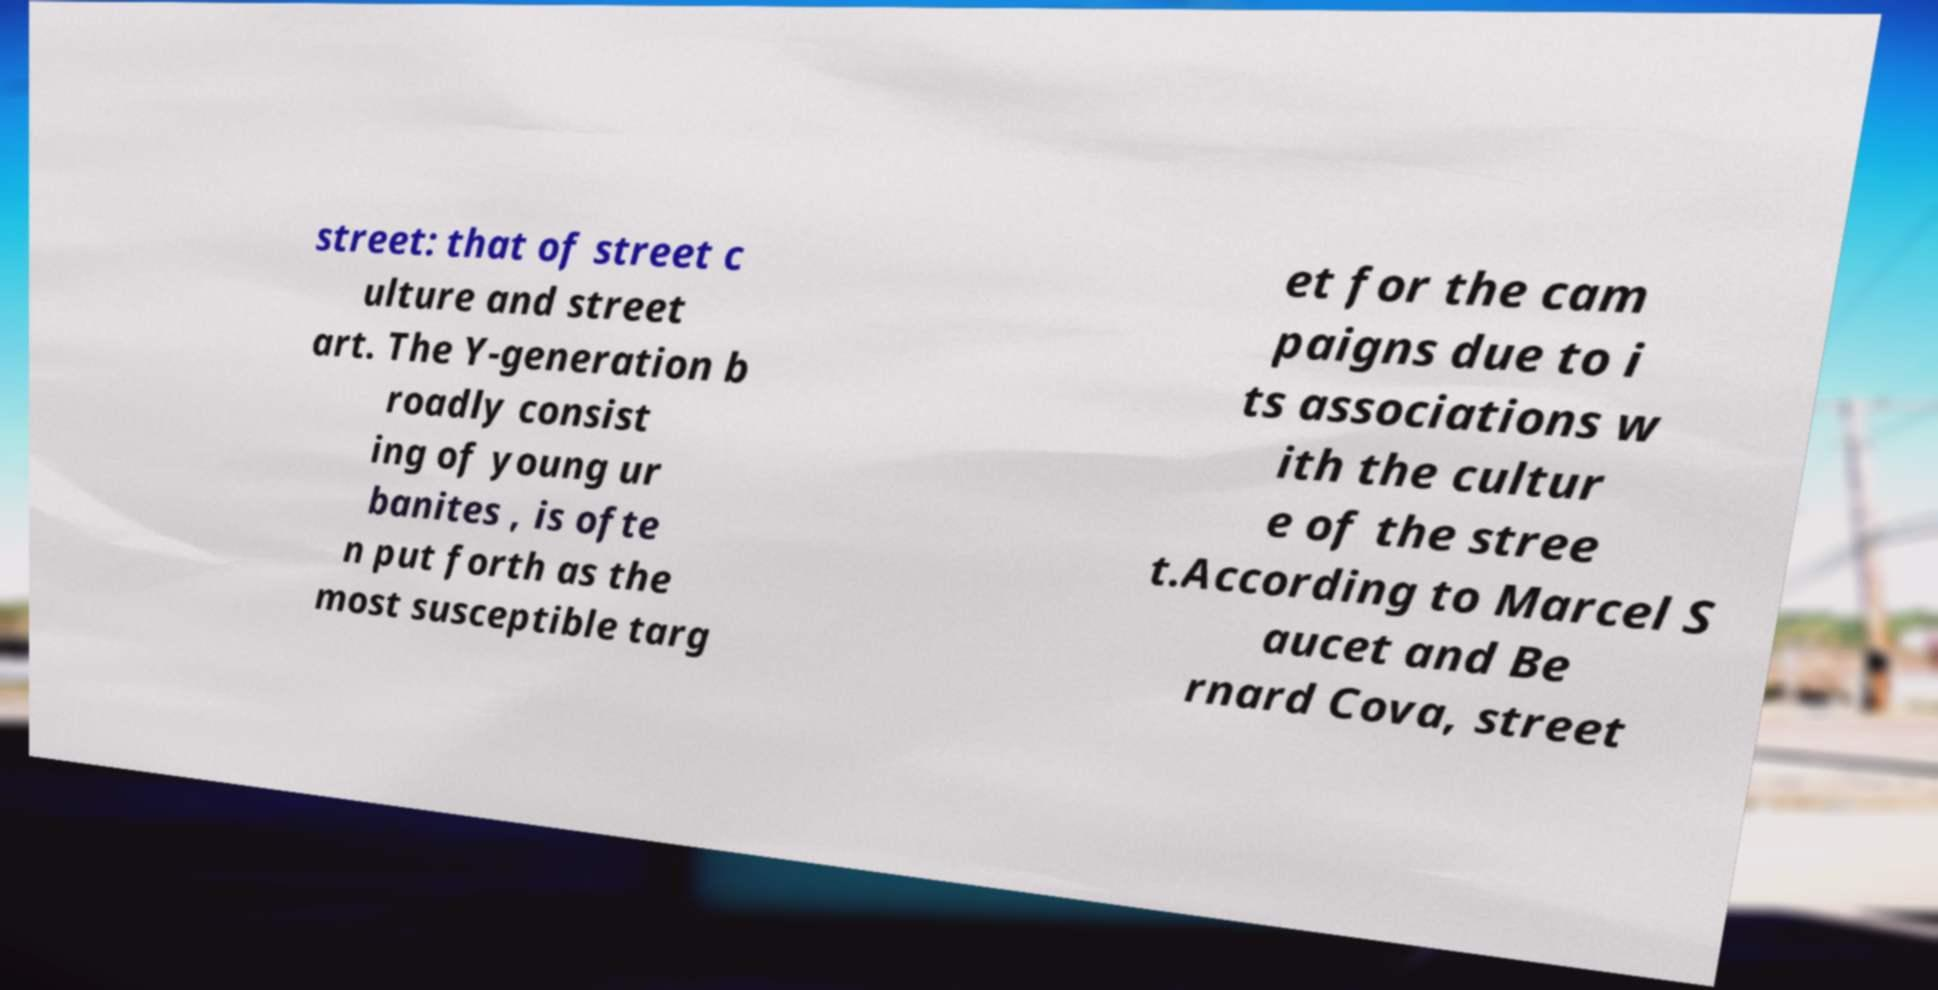Could you extract and type out the text from this image? street: that of street c ulture and street art. The Y-generation b roadly consist ing of young ur banites , is ofte n put forth as the most susceptible targ et for the cam paigns due to i ts associations w ith the cultur e of the stree t.According to Marcel S aucet and Be rnard Cova, street 